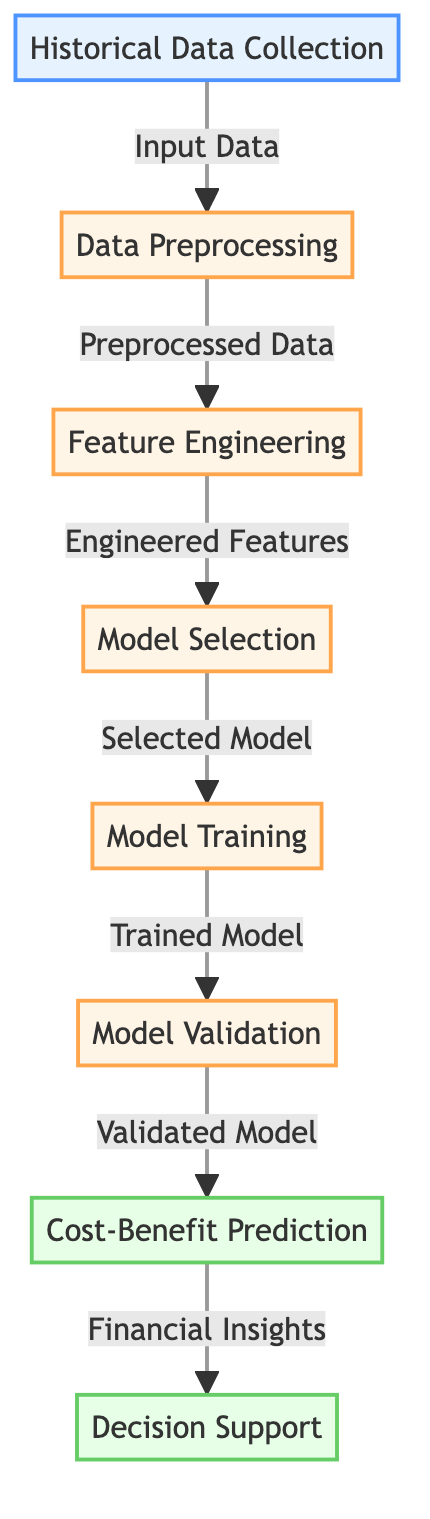What is the first step in the diagram? The first step is labeled as "Historical Data Collection," which represents the initial action in the workflow.
Answer: Historical Data Collection How many major processes are in the diagram? The diagram contains four major processes: Data Preprocessing, Feature Engineering, Model Selection, and Model Training.
Answer: Four What type of data is the output from Model Validation? The output from Model Validation is "Validated Model," which is a confirmed version of the model ready for predictions.
Answer: Validated Model Which step follows Feature Engineering? The step that follows Feature Engineering is Model Selection, indicating a progression from creating features to choosing the appropriate model for training.
Answer: Model Selection From which process does Cost-Benefit Prediction receive its input? Cost-Benefit Prediction receives its input from Model Validation, showing that the predictions are based on the validated model's performance.
Answer: Model Validation What is the last outcome in the flowchart? The last outcome is "Decision Support," which suggests that the financial insights obtained will aid in making decisions.
Answer: Decision Support What flow direction is observed from Model Training to Model Validation? The flow direction is forwards, indicating that once the model is trained, it proceeds to the validation stage for performance assessment.
Answer: Forwards Which node provides the immediate input to Cost-Benefit Prediction? The immediate input to Cost-Benefit Prediction is the "Validated Model," which is essential for making accurate financial predictions.
Answer: Validated Model 